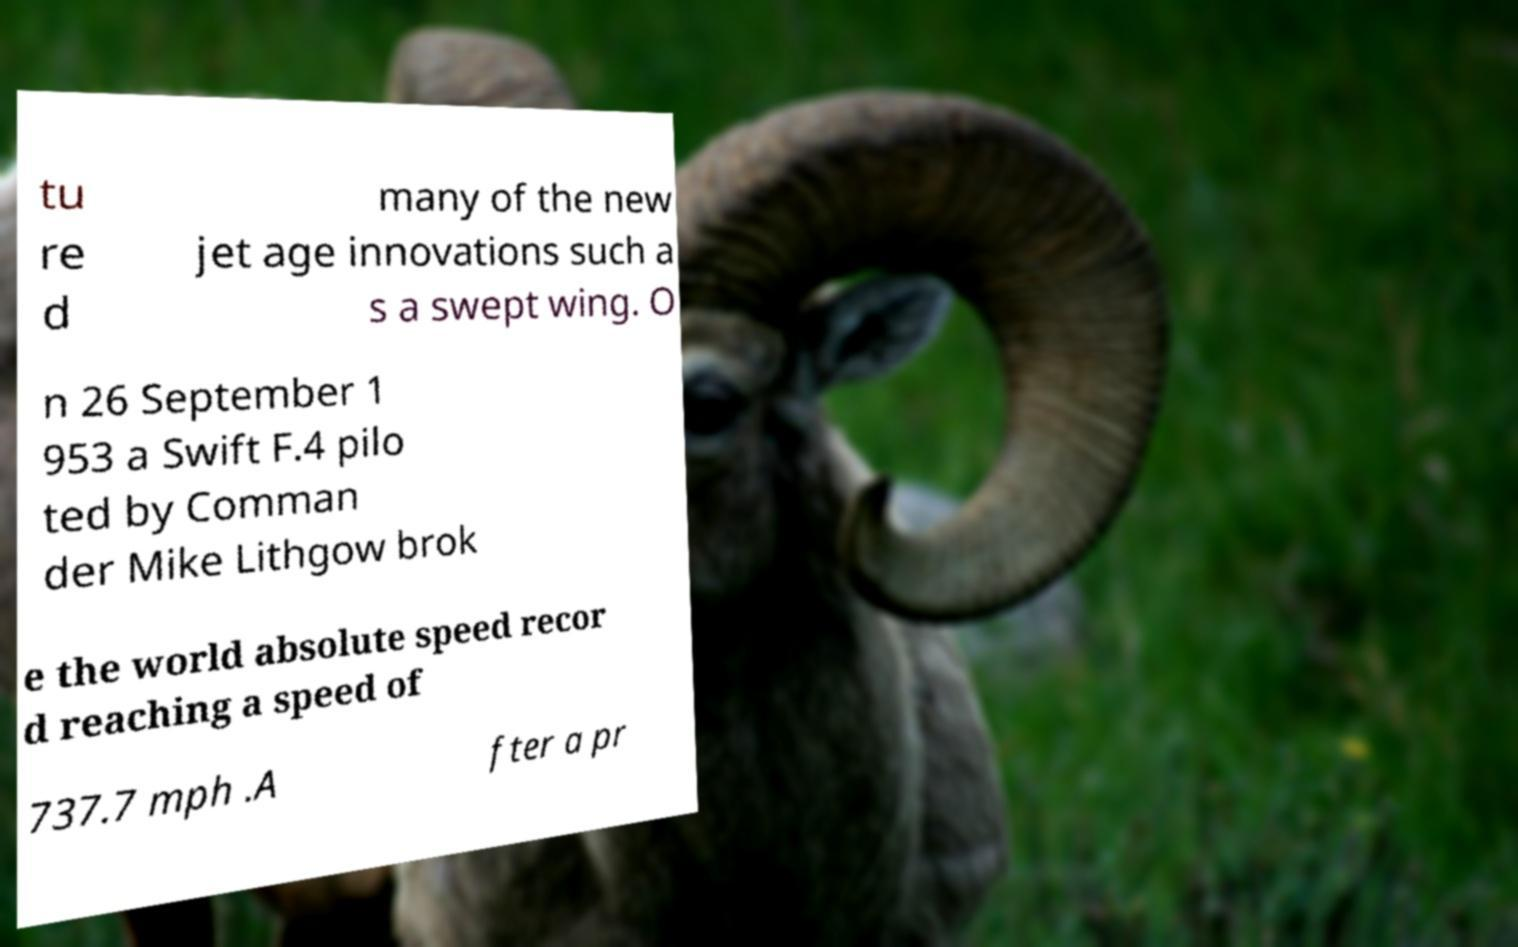Please identify and transcribe the text found in this image. tu re d many of the new jet age innovations such a s a swept wing. O n 26 September 1 953 a Swift F.4 pilo ted by Comman der Mike Lithgow brok e the world absolute speed recor d reaching a speed of 737.7 mph .A fter a pr 